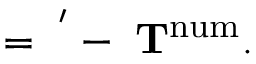<formula> <loc_0><loc_0><loc_500><loc_500>\Pi = \Pi ^ { ^ { \prime } } - \zeta T ^ { n u m } .</formula> 